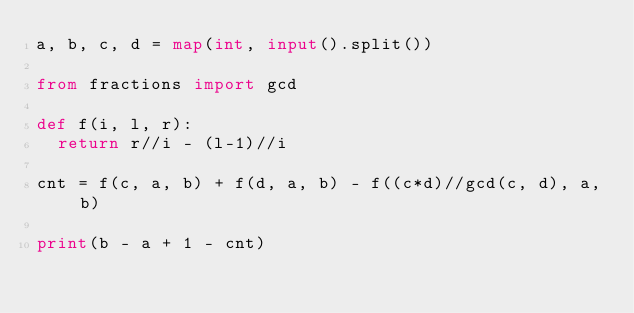<code> <loc_0><loc_0><loc_500><loc_500><_Python_>a, b, c, d = map(int, input().split())

from fractions import gcd

def f(i, l, r):
  return r//i - (l-1)//i

cnt = f(c, a, b) + f(d, a, b) - f((c*d)//gcd(c, d), a, b)

print(b - a + 1 - cnt)
  
</code> 